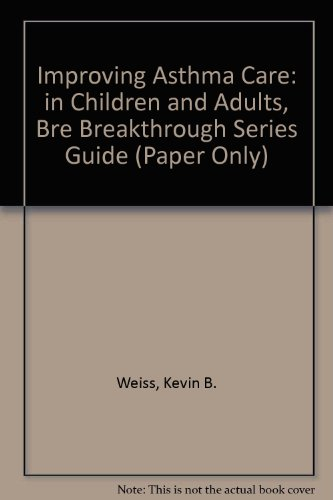Is this a fitness book? While classified under 'Health, Fitness & Dieting', the primary focus is on health care and asthma management rather than general fitness or physical exercise. 